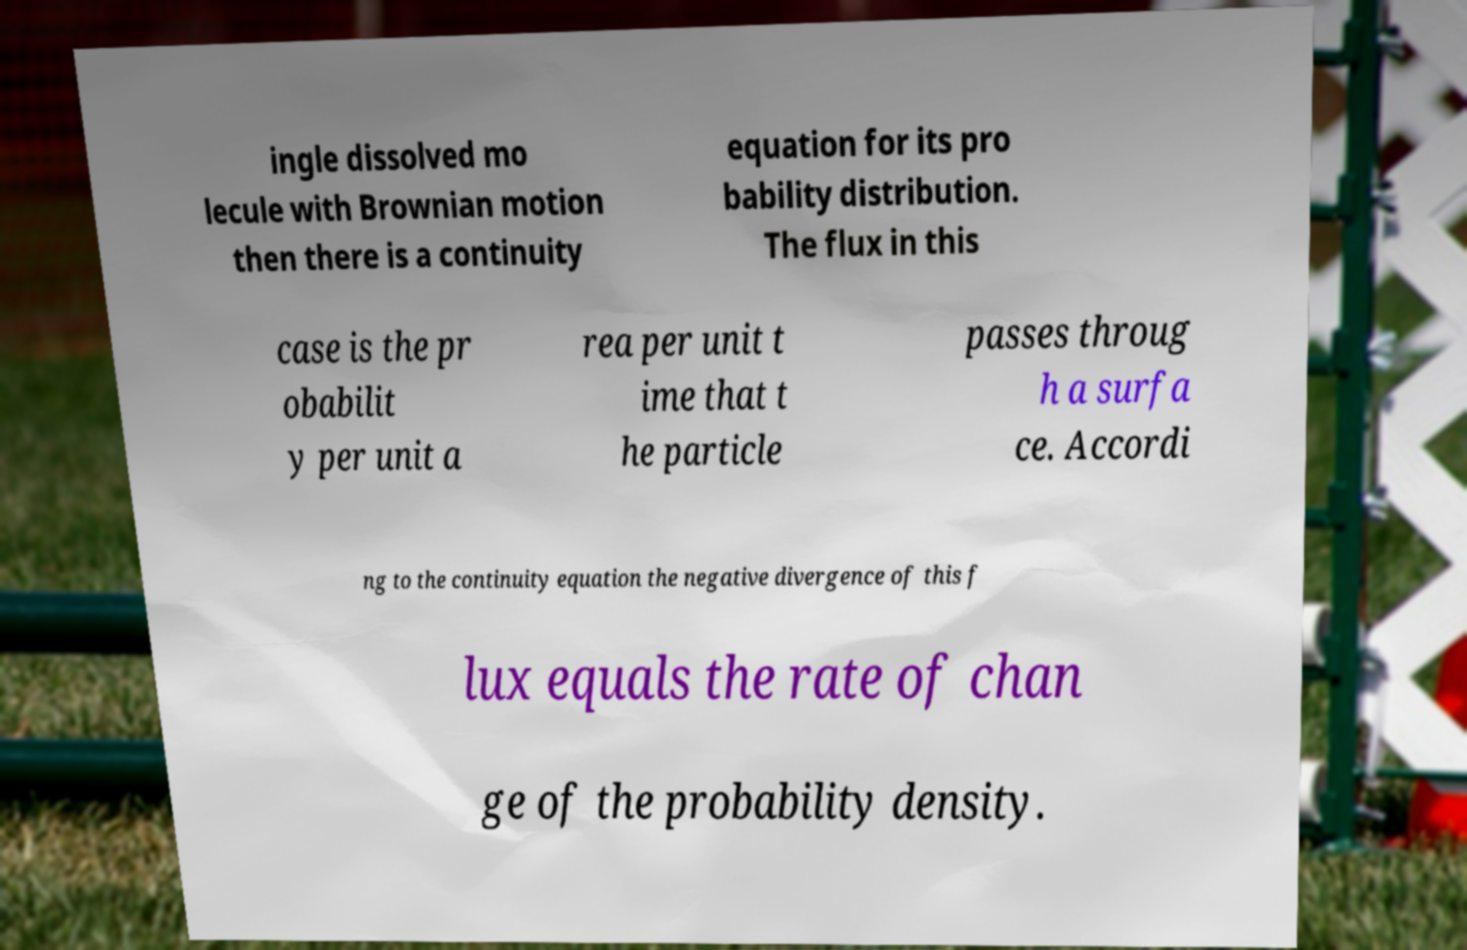What messages or text are displayed in this image? I need them in a readable, typed format. ingle dissolved mo lecule with Brownian motion then there is a continuity equation for its pro bability distribution. The flux in this case is the pr obabilit y per unit a rea per unit t ime that t he particle passes throug h a surfa ce. Accordi ng to the continuity equation the negative divergence of this f lux equals the rate of chan ge of the probability density. 